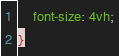<code> <loc_0><loc_0><loc_500><loc_500><_CSS_>	font-size: 4vh;
}</code> 